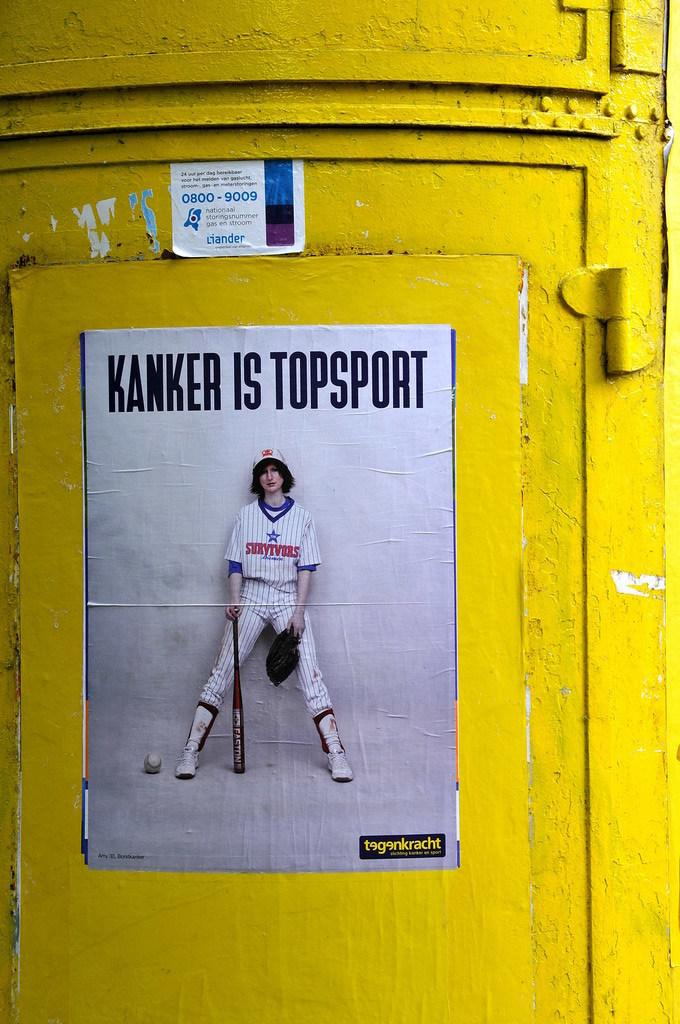<image>
Write a terse but informative summary of the picture. An ad has the phrase kanker is topsport above a baseball player. 